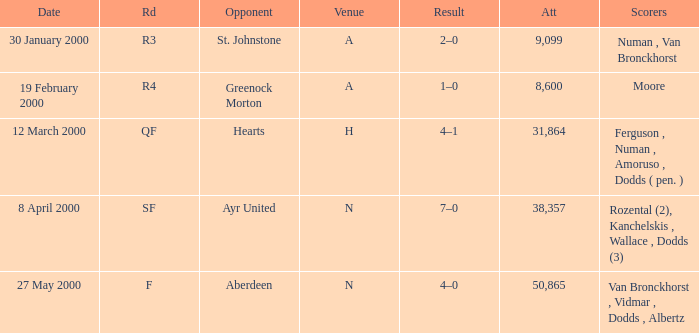Who was in a with opponent St. Johnstone? Numan , Van Bronckhorst. 